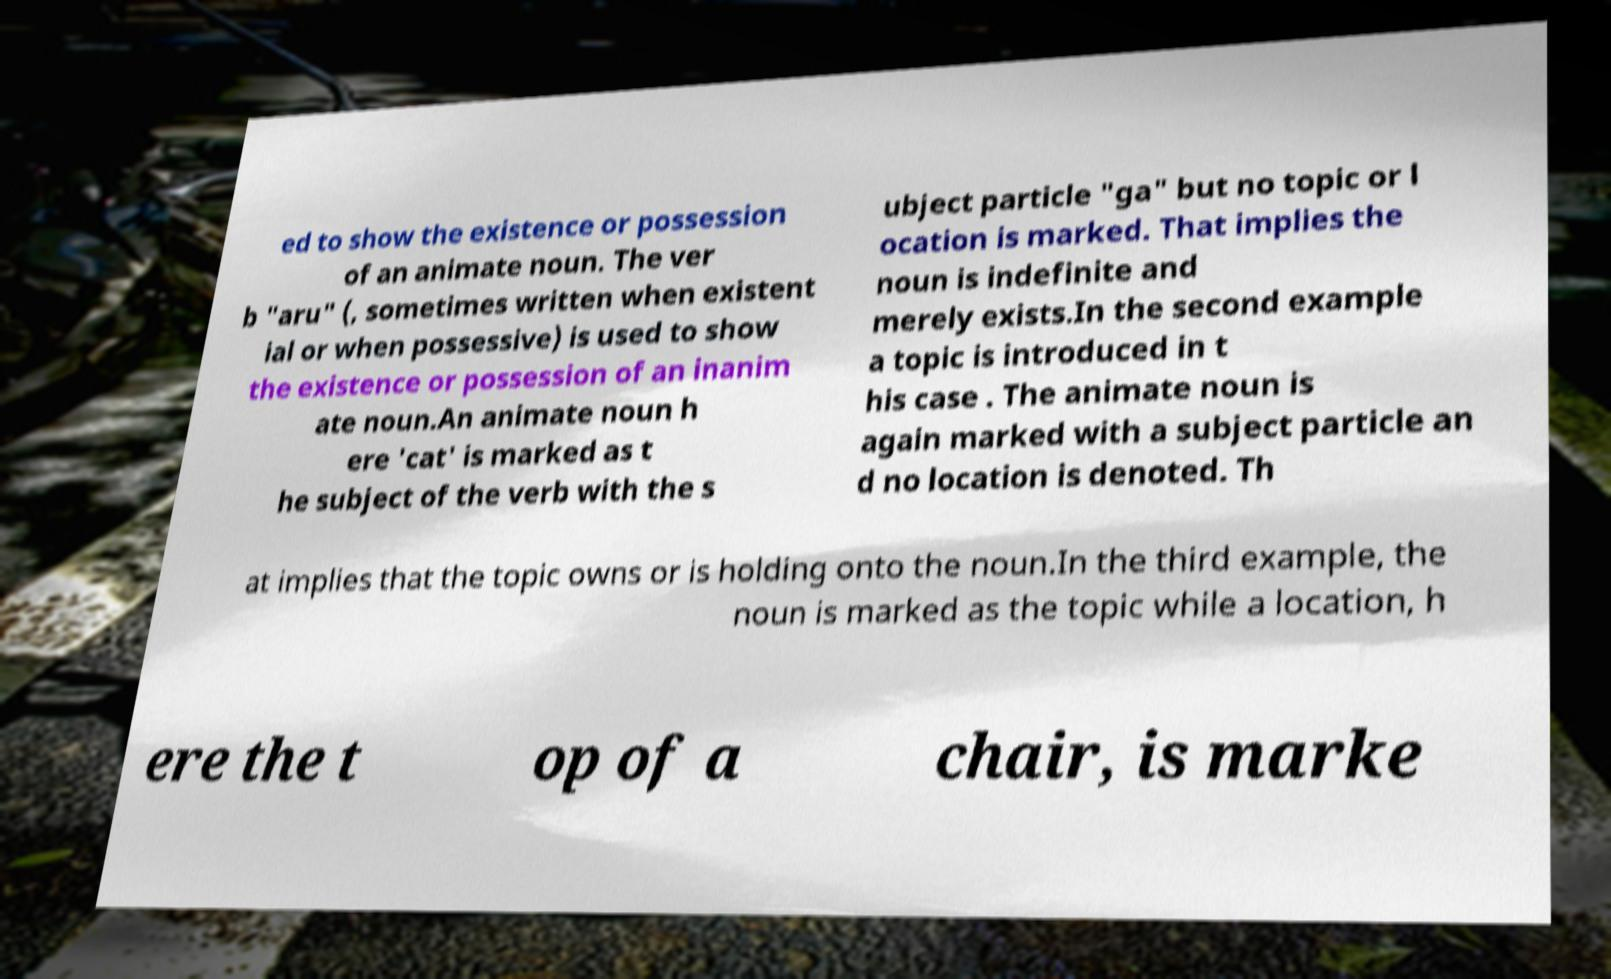Could you extract and type out the text from this image? ed to show the existence or possession of an animate noun. The ver b "aru" (, sometimes written when existent ial or when possessive) is used to show the existence or possession of an inanim ate noun.An animate noun h ere 'cat' is marked as t he subject of the verb with the s ubject particle "ga" but no topic or l ocation is marked. That implies the noun is indefinite and merely exists.In the second example a topic is introduced in t his case . The animate noun is again marked with a subject particle an d no location is denoted. Th at implies that the topic owns or is holding onto the noun.In the third example, the noun is marked as the topic while a location, h ere the t op of a chair, is marke 